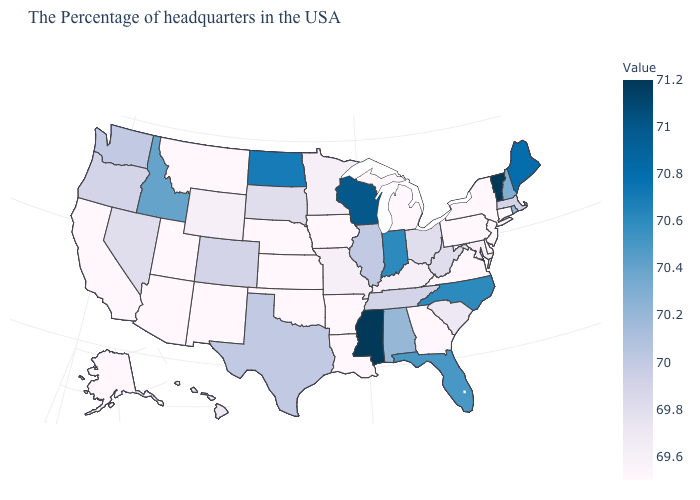Does Delaware have the lowest value in the South?
Short answer required. Yes. Does Rhode Island have a lower value than Florida?
Answer briefly. Yes. Does Hawaii have a lower value than Pennsylvania?
Answer briefly. No. Does Mississippi have the highest value in the South?
Concise answer only. Yes. 